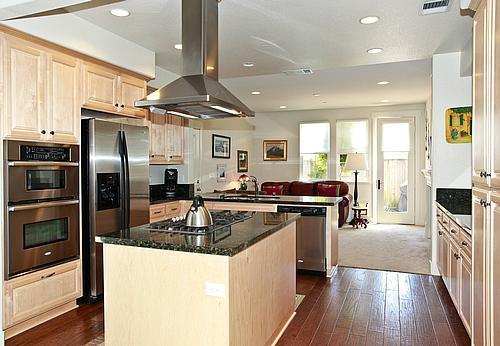What material is the appliances made of?
Concise answer only. Stainless steel. Is this "open concept"?
Write a very short answer. Yes. Is it daytime or nighttime?
Quick response, please. Day. 